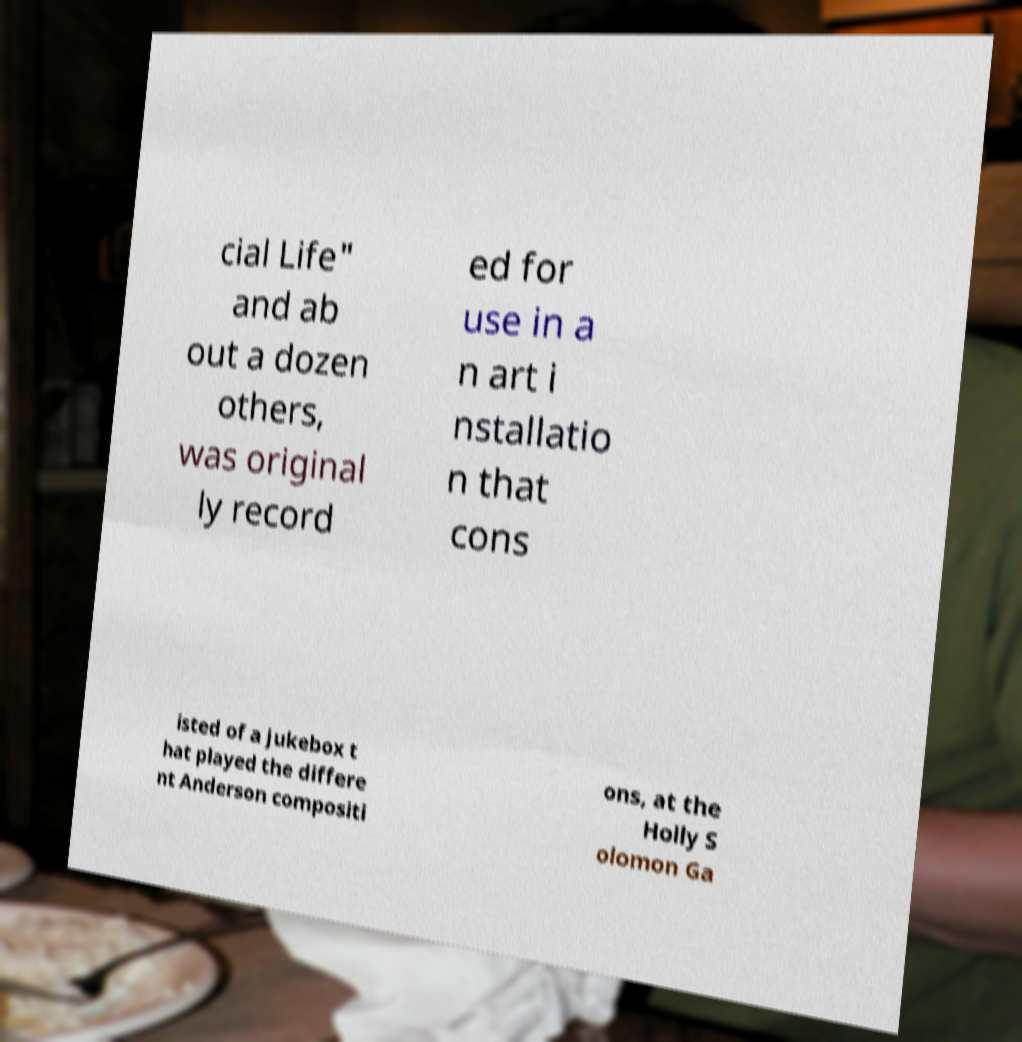What messages or text are displayed in this image? I need them in a readable, typed format. cial Life" and ab out a dozen others, was original ly record ed for use in a n art i nstallatio n that cons isted of a jukebox t hat played the differe nt Anderson compositi ons, at the Holly S olomon Ga 